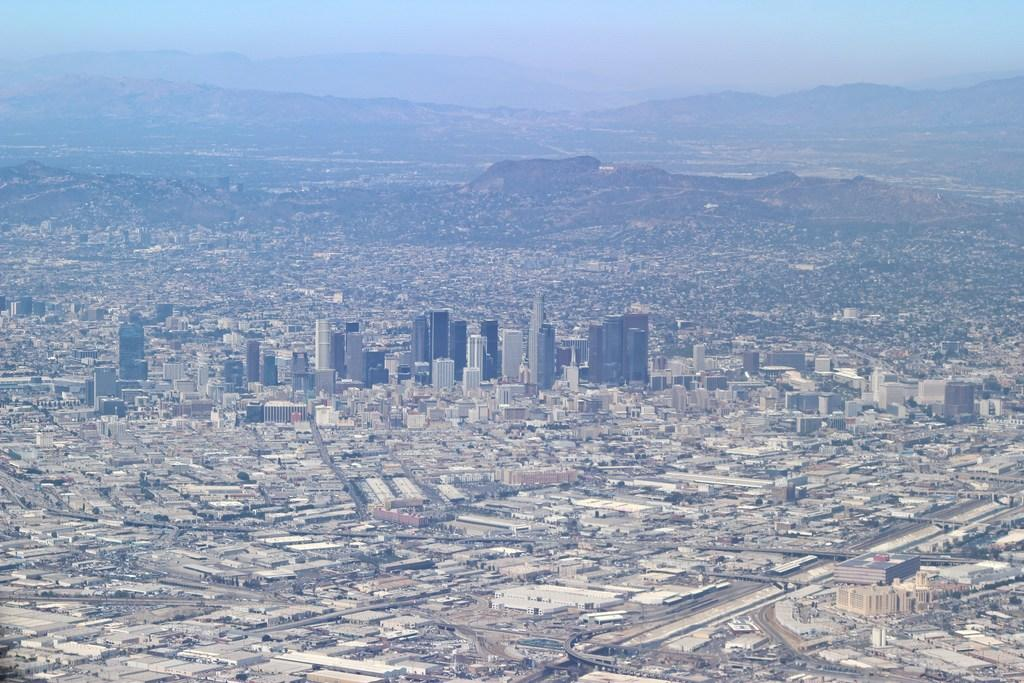What type of structures can be seen in the image? There is a group of buildings in the image. What else can be seen in the image besides the buildings? There are roads visible in the image. What can be seen in the background of the image? There are hills visible in the background of the image. What is visible in the sky in the image? The sky is visible in the image, and it appears cloudy. What type of balloon is floating above the buildings in the image? There is no balloon present in the image; it only features a group of buildings, roads, hills, and a cloudy sky. 